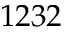Convert formula to latex. <formula><loc_0><loc_0><loc_500><loc_500>1 2 3 2</formula> 